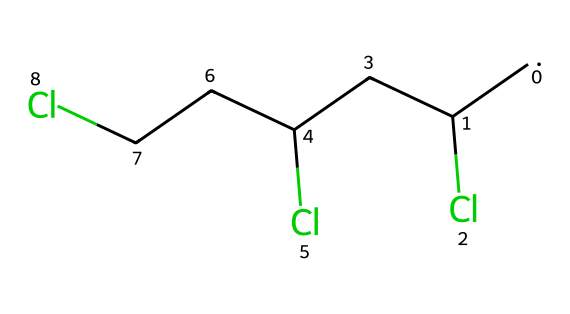What is the molecular formula of this chemical? The SMILES representation indicates there are three carbon atoms (C) and three chlorine atoms (Cl). Therefore, the molecular formula is C3H6Cl3.
Answer: C3H6Cl3 How many carbon atoms are in this compound? The SMILES representation shows that there are three occurrences of "C", indicating three carbon atoms present in the structure.
Answer: 3 What type of bonding is present in this structure? The structure suggests that there are single bonds between the carbon atoms and the chlorine atoms, which is characteristic of saturated compounds.
Answer: single bonds Which functional group is primarily present in this compound? The presence of chlorine atoms attached to the carbon chain indicates that this compound belongs to the class of organochlorides, thus the functional group is halide.
Answer: halide How is this compound classified environmentally? The presence of chlorine atoms can often categorize such compounds as potentially hazardous due to their persistence and toxicity; therefore, it can be classified as an organic pollutant.
Answer: organic pollutant What is the degree of saturation of the compound? Given that all bonds in this structure are single, and it contains only carbon and chlorine (without double or triple bonds), it is fully saturated. Therefore, the degree of saturation is 0.
Answer: 0 Is this compound a cycloalkane? The structure features straight chains of carbon atoms with no cyclic structure indicated; hence, it does not qualify as a cycloalkane.
Answer: no 